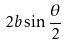<formula> <loc_0><loc_0><loc_500><loc_500>2 b \sin \frac { \theta } { 2 }</formula> 